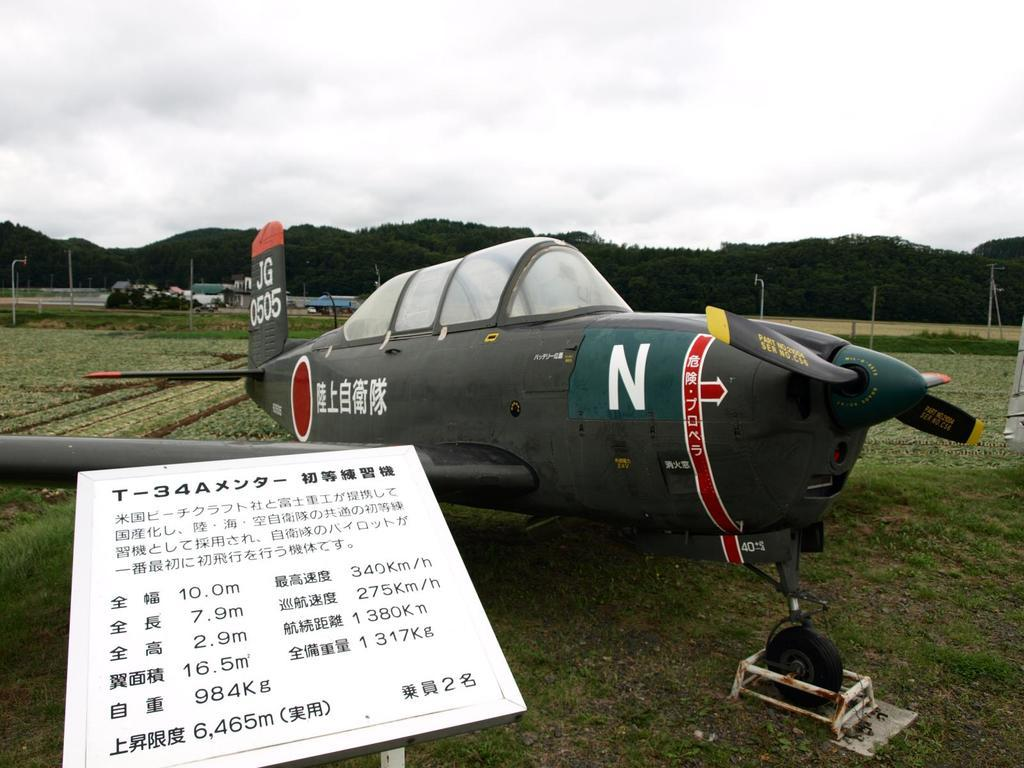What is the main subject of the image? The main subject of the image is an aircraft. What other types of transportation can be seen in the image? There are vehicles in the image. What type of terrain is visible at the bottom of the image? There is grass at the bottom of the image. What is the board used for in the image? The purpose of the board is not clear from the image, but it is visible. What structures can be seen in the background of the image? There are poles in the background of the image. What natural features are visible in the background of the image? There are hills and the sky visible in the background of the image. How many elbows can be seen on the aircraft in the image? There are no elbows visible on the aircraft in the image, as it is a machine and not a living being. What type of duck is present in the image? There are no ducks present in the image. 